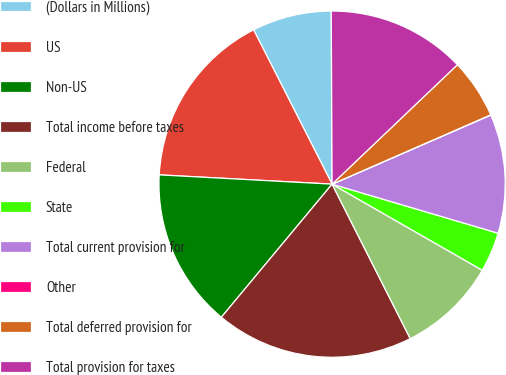Convert chart. <chart><loc_0><loc_0><loc_500><loc_500><pie_chart><fcel>(Dollars in Millions)<fcel>US<fcel>Non-US<fcel>Total income before taxes<fcel>Federal<fcel>State<fcel>Total current provision for<fcel>Other<fcel>Total deferred provision for<fcel>Total provision for taxes<nl><fcel>7.41%<fcel>16.66%<fcel>14.81%<fcel>18.5%<fcel>9.26%<fcel>3.71%<fcel>11.11%<fcel>0.02%<fcel>5.56%<fcel>12.96%<nl></chart> 